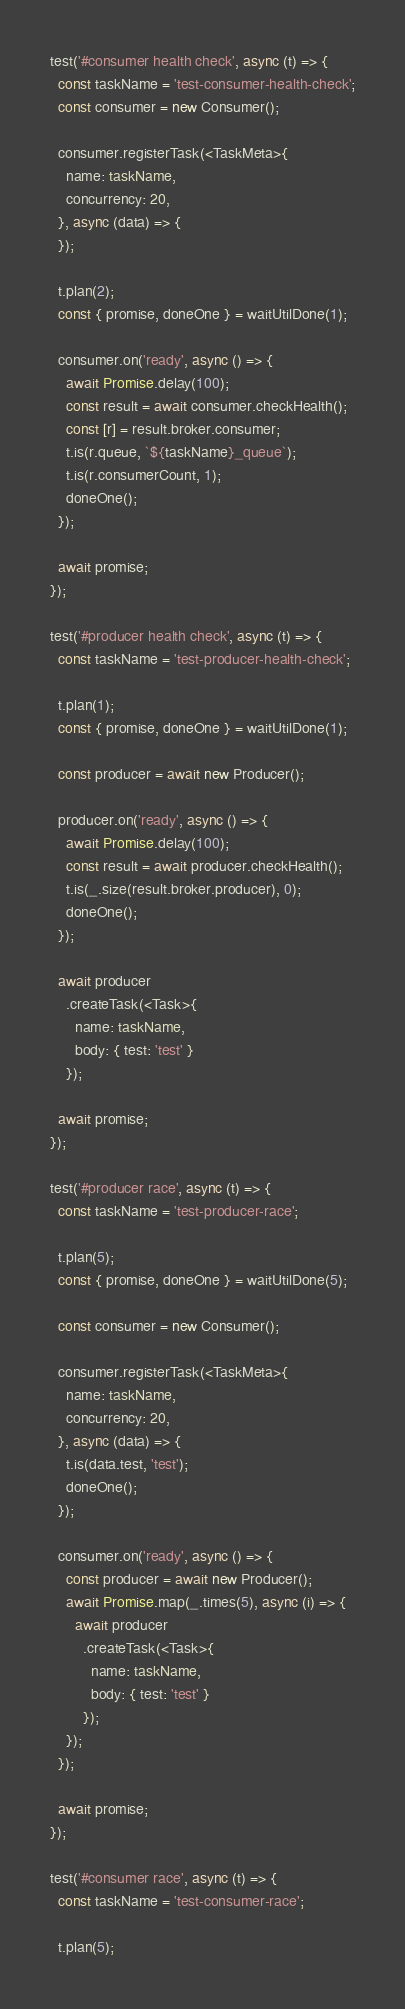Convert code to text. <code><loc_0><loc_0><loc_500><loc_500><_TypeScript_>
test('#consumer health check', async (t) => {
  const taskName = 'test-consumer-health-check';
  const consumer = new Consumer();

  consumer.registerTask(<TaskMeta>{
    name: taskName,
    concurrency: 20,
  }, async (data) => {
  });

  t.plan(2);
  const { promise, doneOne } = waitUtilDone(1);

  consumer.on('ready', async () => {
    await Promise.delay(100);
    const result = await consumer.checkHealth();
    const [r] = result.broker.consumer;
    t.is(r.queue, `${taskName}_queue`);
    t.is(r.consumerCount, 1);
    doneOne();
  });

  await promise;
});

test('#producer health check', async (t) => {
  const taskName = 'test-producer-health-check';

  t.plan(1);
  const { promise, doneOne } = waitUtilDone(1);

  const producer = await new Producer();

  producer.on('ready', async () => {
    await Promise.delay(100);
    const result = await producer.checkHealth();
    t.is(_.size(result.broker.producer), 0);
    doneOne();
  });

  await producer
    .createTask(<Task>{
      name: taskName,
      body: { test: 'test' }
    });

  await promise;
});

test('#producer race', async (t) => {
  const taskName = 'test-producer-race';

  t.plan(5);
  const { promise, doneOne } = waitUtilDone(5);

  const consumer = new Consumer();

  consumer.registerTask(<TaskMeta>{
    name: taskName,
    concurrency: 20,
  }, async (data) => {
    t.is(data.test, 'test');
    doneOne();
  });

  consumer.on('ready', async () => {
    const producer = await new Producer();
    await Promise.map(_.times(5), async (i) => {
      await producer
        .createTask(<Task>{
          name: taskName,
          body: { test: 'test' }
        });
    });
  });

  await promise;
});

test('#consumer race', async (t) => {
  const taskName = 'test-consumer-race';

  t.plan(5);</code> 